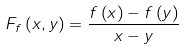Convert formula to latex. <formula><loc_0><loc_0><loc_500><loc_500>F _ { f } \left ( x , y \right ) = \frac { f \left ( x \right ) - f \left ( y \right ) } { x - y }</formula> 